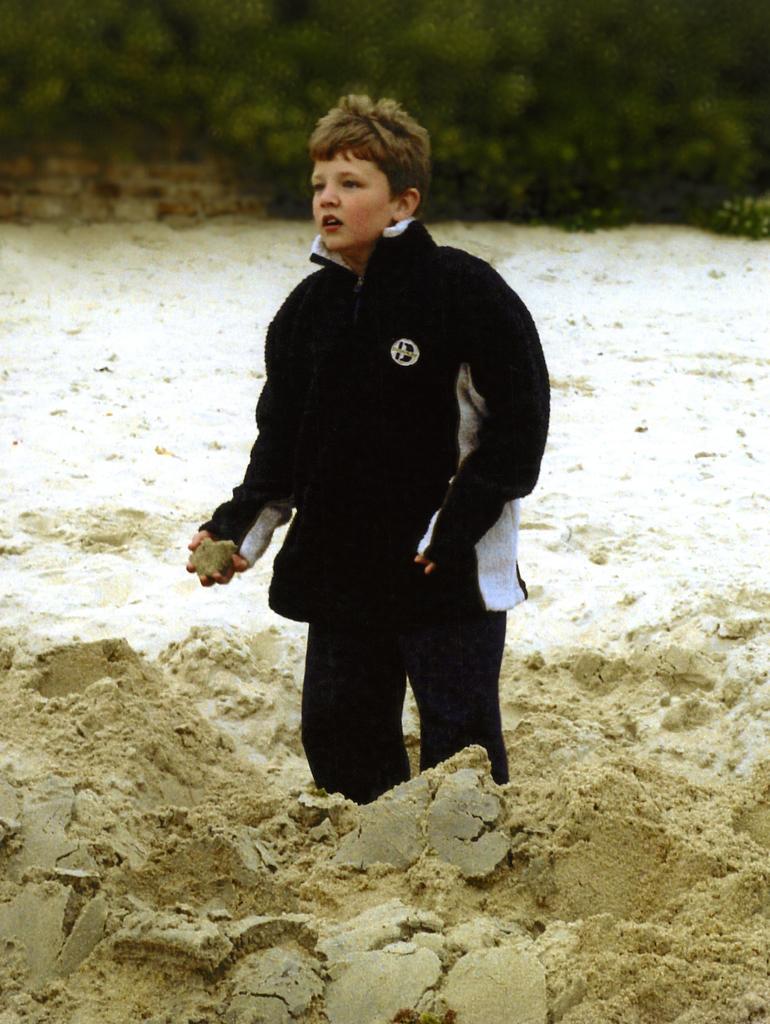In one or two sentences, can you explain what this image depicts? In the image we can see a boy standing, wearing clothes and holding mud in hand. Here we can see mud and the background is blurred. 